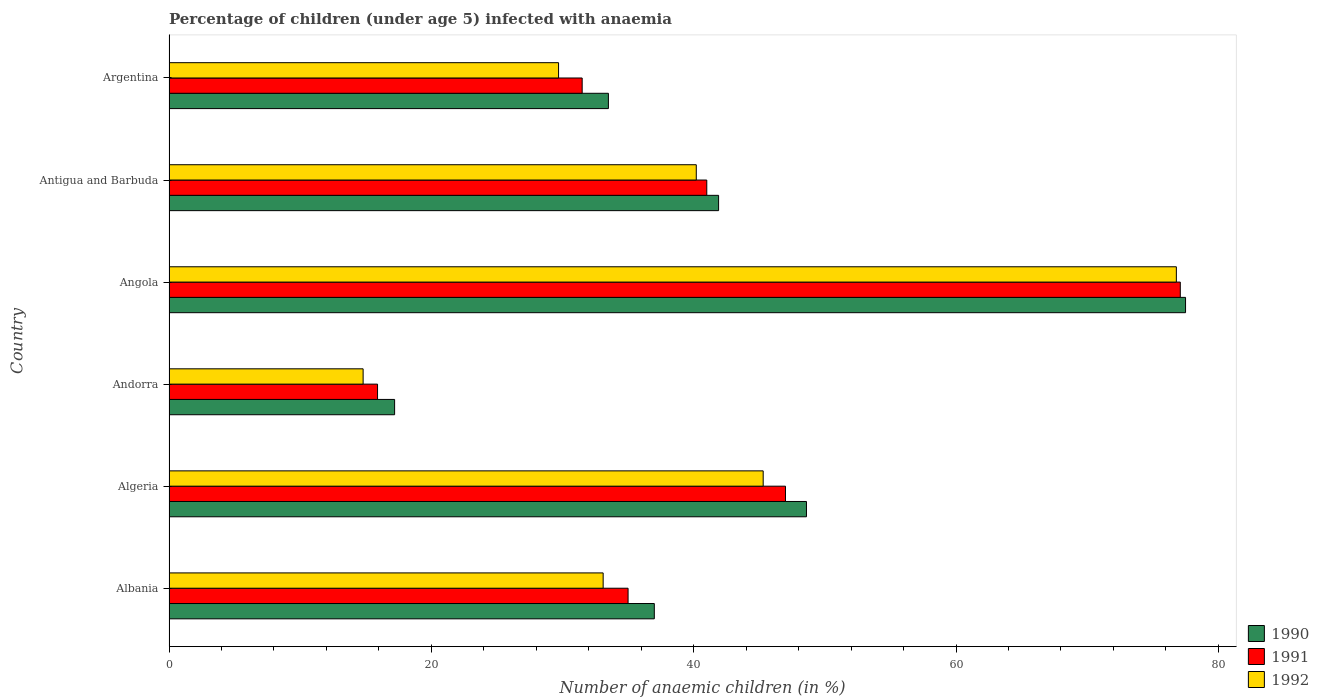How many different coloured bars are there?
Offer a very short reply. 3. Are the number of bars per tick equal to the number of legend labels?
Your response must be concise. Yes. Are the number of bars on each tick of the Y-axis equal?
Ensure brevity in your answer.  Yes. How many bars are there on the 5th tick from the bottom?
Your answer should be compact. 3. What is the label of the 6th group of bars from the top?
Offer a very short reply. Albania. Across all countries, what is the maximum percentage of children infected with anaemia in in 1991?
Your response must be concise. 77.1. Across all countries, what is the minimum percentage of children infected with anaemia in in 1991?
Keep it short and to the point. 15.9. In which country was the percentage of children infected with anaemia in in 1992 maximum?
Offer a terse response. Angola. In which country was the percentage of children infected with anaemia in in 1992 minimum?
Provide a succinct answer. Andorra. What is the total percentage of children infected with anaemia in in 1992 in the graph?
Keep it short and to the point. 239.9. What is the difference between the percentage of children infected with anaemia in in 1991 in Albania and that in Algeria?
Offer a very short reply. -12. What is the difference between the percentage of children infected with anaemia in in 1991 in Argentina and the percentage of children infected with anaemia in in 1990 in Antigua and Barbuda?
Offer a very short reply. -10.4. What is the average percentage of children infected with anaemia in in 1991 per country?
Your answer should be compact. 41.25. What is the difference between the percentage of children infected with anaemia in in 1992 and percentage of children infected with anaemia in in 1990 in Angola?
Provide a succinct answer. -0.7. In how many countries, is the percentage of children infected with anaemia in in 1991 greater than 56 %?
Your answer should be very brief. 1. What is the ratio of the percentage of children infected with anaemia in in 1990 in Andorra to that in Argentina?
Offer a very short reply. 0.51. Is the difference between the percentage of children infected with anaemia in in 1992 in Angola and Antigua and Barbuda greater than the difference between the percentage of children infected with anaemia in in 1990 in Angola and Antigua and Barbuda?
Ensure brevity in your answer.  Yes. What is the difference between the highest and the second highest percentage of children infected with anaemia in in 1992?
Make the answer very short. 31.5. What is the difference between the highest and the lowest percentage of children infected with anaemia in in 1990?
Your answer should be compact. 60.3. How many bars are there?
Your answer should be very brief. 18. Are all the bars in the graph horizontal?
Provide a short and direct response. Yes. How many countries are there in the graph?
Your response must be concise. 6. Are the values on the major ticks of X-axis written in scientific E-notation?
Offer a terse response. No. Does the graph contain any zero values?
Provide a short and direct response. No. How are the legend labels stacked?
Provide a short and direct response. Vertical. What is the title of the graph?
Keep it short and to the point. Percentage of children (under age 5) infected with anaemia. What is the label or title of the X-axis?
Your response must be concise. Number of anaemic children (in %). What is the Number of anaemic children (in %) in 1990 in Albania?
Give a very brief answer. 37. What is the Number of anaemic children (in %) in 1992 in Albania?
Keep it short and to the point. 33.1. What is the Number of anaemic children (in %) in 1990 in Algeria?
Your response must be concise. 48.6. What is the Number of anaemic children (in %) in 1992 in Algeria?
Give a very brief answer. 45.3. What is the Number of anaemic children (in %) in 1990 in Andorra?
Your answer should be very brief. 17.2. What is the Number of anaemic children (in %) in 1992 in Andorra?
Make the answer very short. 14.8. What is the Number of anaemic children (in %) in 1990 in Angola?
Make the answer very short. 77.5. What is the Number of anaemic children (in %) of 1991 in Angola?
Offer a very short reply. 77.1. What is the Number of anaemic children (in %) in 1992 in Angola?
Offer a terse response. 76.8. What is the Number of anaemic children (in %) in 1990 in Antigua and Barbuda?
Provide a short and direct response. 41.9. What is the Number of anaemic children (in %) in 1991 in Antigua and Barbuda?
Your answer should be very brief. 41. What is the Number of anaemic children (in %) in 1992 in Antigua and Barbuda?
Make the answer very short. 40.2. What is the Number of anaemic children (in %) of 1990 in Argentina?
Keep it short and to the point. 33.5. What is the Number of anaemic children (in %) of 1991 in Argentina?
Offer a terse response. 31.5. What is the Number of anaemic children (in %) in 1992 in Argentina?
Offer a terse response. 29.7. Across all countries, what is the maximum Number of anaemic children (in %) in 1990?
Offer a very short reply. 77.5. Across all countries, what is the maximum Number of anaemic children (in %) of 1991?
Give a very brief answer. 77.1. Across all countries, what is the maximum Number of anaemic children (in %) of 1992?
Keep it short and to the point. 76.8. Across all countries, what is the minimum Number of anaemic children (in %) of 1990?
Your response must be concise. 17.2. Across all countries, what is the minimum Number of anaemic children (in %) in 1992?
Ensure brevity in your answer.  14.8. What is the total Number of anaemic children (in %) of 1990 in the graph?
Ensure brevity in your answer.  255.7. What is the total Number of anaemic children (in %) in 1991 in the graph?
Your response must be concise. 247.5. What is the total Number of anaemic children (in %) of 1992 in the graph?
Make the answer very short. 239.9. What is the difference between the Number of anaemic children (in %) in 1990 in Albania and that in Algeria?
Give a very brief answer. -11.6. What is the difference between the Number of anaemic children (in %) in 1991 in Albania and that in Algeria?
Your answer should be compact. -12. What is the difference between the Number of anaemic children (in %) of 1992 in Albania and that in Algeria?
Provide a short and direct response. -12.2. What is the difference between the Number of anaemic children (in %) of 1990 in Albania and that in Andorra?
Your response must be concise. 19.8. What is the difference between the Number of anaemic children (in %) of 1992 in Albania and that in Andorra?
Make the answer very short. 18.3. What is the difference between the Number of anaemic children (in %) in 1990 in Albania and that in Angola?
Make the answer very short. -40.5. What is the difference between the Number of anaemic children (in %) in 1991 in Albania and that in Angola?
Give a very brief answer. -42.1. What is the difference between the Number of anaemic children (in %) in 1992 in Albania and that in Angola?
Your answer should be very brief. -43.7. What is the difference between the Number of anaemic children (in %) of 1992 in Albania and that in Antigua and Barbuda?
Offer a terse response. -7.1. What is the difference between the Number of anaemic children (in %) in 1991 in Albania and that in Argentina?
Keep it short and to the point. 3.5. What is the difference between the Number of anaemic children (in %) in 1990 in Algeria and that in Andorra?
Your answer should be compact. 31.4. What is the difference between the Number of anaemic children (in %) of 1991 in Algeria and that in Andorra?
Your response must be concise. 31.1. What is the difference between the Number of anaemic children (in %) of 1992 in Algeria and that in Andorra?
Your answer should be very brief. 30.5. What is the difference between the Number of anaemic children (in %) of 1990 in Algeria and that in Angola?
Your answer should be compact. -28.9. What is the difference between the Number of anaemic children (in %) in 1991 in Algeria and that in Angola?
Keep it short and to the point. -30.1. What is the difference between the Number of anaemic children (in %) of 1992 in Algeria and that in Angola?
Your response must be concise. -31.5. What is the difference between the Number of anaemic children (in %) in 1990 in Algeria and that in Antigua and Barbuda?
Offer a terse response. 6.7. What is the difference between the Number of anaemic children (in %) of 1991 in Algeria and that in Antigua and Barbuda?
Make the answer very short. 6. What is the difference between the Number of anaemic children (in %) in 1991 in Algeria and that in Argentina?
Ensure brevity in your answer.  15.5. What is the difference between the Number of anaemic children (in %) in 1990 in Andorra and that in Angola?
Your answer should be compact. -60.3. What is the difference between the Number of anaemic children (in %) in 1991 in Andorra and that in Angola?
Keep it short and to the point. -61.2. What is the difference between the Number of anaemic children (in %) of 1992 in Andorra and that in Angola?
Give a very brief answer. -62. What is the difference between the Number of anaemic children (in %) of 1990 in Andorra and that in Antigua and Barbuda?
Keep it short and to the point. -24.7. What is the difference between the Number of anaemic children (in %) of 1991 in Andorra and that in Antigua and Barbuda?
Your answer should be very brief. -25.1. What is the difference between the Number of anaemic children (in %) of 1992 in Andorra and that in Antigua and Barbuda?
Offer a very short reply. -25.4. What is the difference between the Number of anaemic children (in %) of 1990 in Andorra and that in Argentina?
Offer a very short reply. -16.3. What is the difference between the Number of anaemic children (in %) in 1991 in Andorra and that in Argentina?
Keep it short and to the point. -15.6. What is the difference between the Number of anaemic children (in %) of 1992 in Andorra and that in Argentina?
Keep it short and to the point. -14.9. What is the difference between the Number of anaemic children (in %) of 1990 in Angola and that in Antigua and Barbuda?
Ensure brevity in your answer.  35.6. What is the difference between the Number of anaemic children (in %) of 1991 in Angola and that in Antigua and Barbuda?
Make the answer very short. 36.1. What is the difference between the Number of anaemic children (in %) in 1992 in Angola and that in Antigua and Barbuda?
Your answer should be very brief. 36.6. What is the difference between the Number of anaemic children (in %) in 1991 in Angola and that in Argentina?
Provide a succinct answer. 45.6. What is the difference between the Number of anaemic children (in %) of 1992 in Angola and that in Argentina?
Give a very brief answer. 47.1. What is the difference between the Number of anaemic children (in %) in 1990 in Albania and the Number of anaemic children (in %) in 1991 in Algeria?
Make the answer very short. -10. What is the difference between the Number of anaemic children (in %) in 1991 in Albania and the Number of anaemic children (in %) in 1992 in Algeria?
Make the answer very short. -10.3. What is the difference between the Number of anaemic children (in %) in 1990 in Albania and the Number of anaemic children (in %) in 1991 in Andorra?
Provide a short and direct response. 21.1. What is the difference between the Number of anaemic children (in %) of 1990 in Albania and the Number of anaemic children (in %) of 1992 in Andorra?
Your answer should be very brief. 22.2. What is the difference between the Number of anaemic children (in %) of 1991 in Albania and the Number of anaemic children (in %) of 1992 in Andorra?
Provide a short and direct response. 20.2. What is the difference between the Number of anaemic children (in %) in 1990 in Albania and the Number of anaemic children (in %) in 1991 in Angola?
Your response must be concise. -40.1. What is the difference between the Number of anaemic children (in %) in 1990 in Albania and the Number of anaemic children (in %) in 1992 in Angola?
Ensure brevity in your answer.  -39.8. What is the difference between the Number of anaemic children (in %) of 1991 in Albania and the Number of anaemic children (in %) of 1992 in Angola?
Make the answer very short. -41.8. What is the difference between the Number of anaemic children (in %) in 1990 in Albania and the Number of anaemic children (in %) in 1991 in Antigua and Barbuda?
Ensure brevity in your answer.  -4. What is the difference between the Number of anaemic children (in %) of 1990 in Albania and the Number of anaemic children (in %) of 1991 in Argentina?
Provide a succinct answer. 5.5. What is the difference between the Number of anaemic children (in %) of 1990 in Algeria and the Number of anaemic children (in %) of 1991 in Andorra?
Keep it short and to the point. 32.7. What is the difference between the Number of anaemic children (in %) in 1990 in Algeria and the Number of anaemic children (in %) in 1992 in Andorra?
Ensure brevity in your answer.  33.8. What is the difference between the Number of anaemic children (in %) in 1991 in Algeria and the Number of anaemic children (in %) in 1992 in Andorra?
Give a very brief answer. 32.2. What is the difference between the Number of anaemic children (in %) of 1990 in Algeria and the Number of anaemic children (in %) of 1991 in Angola?
Offer a terse response. -28.5. What is the difference between the Number of anaemic children (in %) in 1990 in Algeria and the Number of anaemic children (in %) in 1992 in Angola?
Ensure brevity in your answer.  -28.2. What is the difference between the Number of anaemic children (in %) in 1991 in Algeria and the Number of anaemic children (in %) in 1992 in Angola?
Keep it short and to the point. -29.8. What is the difference between the Number of anaemic children (in %) in 1991 in Algeria and the Number of anaemic children (in %) in 1992 in Antigua and Barbuda?
Keep it short and to the point. 6.8. What is the difference between the Number of anaemic children (in %) of 1990 in Algeria and the Number of anaemic children (in %) of 1992 in Argentina?
Keep it short and to the point. 18.9. What is the difference between the Number of anaemic children (in %) of 1990 in Andorra and the Number of anaemic children (in %) of 1991 in Angola?
Ensure brevity in your answer.  -59.9. What is the difference between the Number of anaemic children (in %) in 1990 in Andorra and the Number of anaemic children (in %) in 1992 in Angola?
Your answer should be very brief. -59.6. What is the difference between the Number of anaemic children (in %) in 1991 in Andorra and the Number of anaemic children (in %) in 1992 in Angola?
Offer a terse response. -60.9. What is the difference between the Number of anaemic children (in %) in 1990 in Andorra and the Number of anaemic children (in %) in 1991 in Antigua and Barbuda?
Offer a terse response. -23.8. What is the difference between the Number of anaemic children (in %) in 1990 in Andorra and the Number of anaemic children (in %) in 1992 in Antigua and Barbuda?
Provide a short and direct response. -23. What is the difference between the Number of anaemic children (in %) of 1991 in Andorra and the Number of anaemic children (in %) of 1992 in Antigua and Barbuda?
Your answer should be very brief. -24.3. What is the difference between the Number of anaemic children (in %) of 1990 in Andorra and the Number of anaemic children (in %) of 1991 in Argentina?
Give a very brief answer. -14.3. What is the difference between the Number of anaemic children (in %) in 1990 in Andorra and the Number of anaemic children (in %) in 1992 in Argentina?
Your answer should be very brief. -12.5. What is the difference between the Number of anaemic children (in %) in 1991 in Andorra and the Number of anaemic children (in %) in 1992 in Argentina?
Make the answer very short. -13.8. What is the difference between the Number of anaemic children (in %) in 1990 in Angola and the Number of anaemic children (in %) in 1991 in Antigua and Barbuda?
Provide a short and direct response. 36.5. What is the difference between the Number of anaemic children (in %) of 1990 in Angola and the Number of anaemic children (in %) of 1992 in Antigua and Barbuda?
Give a very brief answer. 37.3. What is the difference between the Number of anaemic children (in %) in 1991 in Angola and the Number of anaemic children (in %) in 1992 in Antigua and Barbuda?
Ensure brevity in your answer.  36.9. What is the difference between the Number of anaemic children (in %) in 1990 in Angola and the Number of anaemic children (in %) in 1992 in Argentina?
Offer a very short reply. 47.8. What is the difference between the Number of anaemic children (in %) in 1991 in Angola and the Number of anaemic children (in %) in 1992 in Argentina?
Your response must be concise. 47.4. What is the average Number of anaemic children (in %) of 1990 per country?
Offer a very short reply. 42.62. What is the average Number of anaemic children (in %) of 1991 per country?
Your answer should be very brief. 41.25. What is the average Number of anaemic children (in %) in 1992 per country?
Offer a very short reply. 39.98. What is the difference between the Number of anaemic children (in %) in 1990 and Number of anaemic children (in %) in 1991 in Albania?
Make the answer very short. 2. What is the difference between the Number of anaemic children (in %) in 1990 and Number of anaemic children (in %) in 1991 in Algeria?
Your response must be concise. 1.6. What is the difference between the Number of anaemic children (in %) in 1990 and Number of anaemic children (in %) in 1992 in Algeria?
Ensure brevity in your answer.  3.3. What is the difference between the Number of anaemic children (in %) in 1991 and Number of anaemic children (in %) in 1992 in Algeria?
Your answer should be compact. 1.7. What is the difference between the Number of anaemic children (in %) in 1990 and Number of anaemic children (in %) in 1991 in Andorra?
Make the answer very short. 1.3. What is the difference between the Number of anaemic children (in %) in 1990 and Number of anaemic children (in %) in 1992 in Andorra?
Offer a terse response. 2.4. What is the difference between the Number of anaemic children (in %) of 1990 and Number of anaemic children (in %) of 1992 in Angola?
Provide a short and direct response. 0.7. What is the difference between the Number of anaemic children (in %) of 1991 and Number of anaemic children (in %) of 1992 in Angola?
Give a very brief answer. 0.3. What is the difference between the Number of anaemic children (in %) in 1990 and Number of anaemic children (in %) in 1991 in Antigua and Barbuda?
Ensure brevity in your answer.  0.9. What is the difference between the Number of anaemic children (in %) of 1990 and Number of anaemic children (in %) of 1992 in Antigua and Barbuda?
Your answer should be very brief. 1.7. What is the difference between the Number of anaemic children (in %) in 1990 and Number of anaemic children (in %) in 1991 in Argentina?
Make the answer very short. 2. What is the ratio of the Number of anaemic children (in %) in 1990 in Albania to that in Algeria?
Give a very brief answer. 0.76. What is the ratio of the Number of anaemic children (in %) in 1991 in Albania to that in Algeria?
Provide a short and direct response. 0.74. What is the ratio of the Number of anaemic children (in %) in 1992 in Albania to that in Algeria?
Provide a short and direct response. 0.73. What is the ratio of the Number of anaemic children (in %) of 1990 in Albania to that in Andorra?
Your answer should be very brief. 2.15. What is the ratio of the Number of anaemic children (in %) in 1991 in Albania to that in Andorra?
Provide a short and direct response. 2.2. What is the ratio of the Number of anaemic children (in %) of 1992 in Albania to that in Andorra?
Offer a terse response. 2.24. What is the ratio of the Number of anaemic children (in %) in 1990 in Albania to that in Angola?
Make the answer very short. 0.48. What is the ratio of the Number of anaemic children (in %) in 1991 in Albania to that in Angola?
Give a very brief answer. 0.45. What is the ratio of the Number of anaemic children (in %) in 1992 in Albania to that in Angola?
Offer a very short reply. 0.43. What is the ratio of the Number of anaemic children (in %) in 1990 in Albania to that in Antigua and Barbuda?
Your answer should be very brief. 0.88. What is the ratio of the Number of anaemic children (in %) in 1991 in Albania to that in Antigua and Barbuda?
Ensure brevity in your answer.  0.85. What is the ratio of the Number of anaemic children (in %) in 1992 in Albania to that in Antigua and Barbuda?
Keep it short and to the point. 0.82. What is the ratio of the Number of anaemic children (in %) of 1990 in Albania to that in Argentina?
Your answer should be very brief. 1.1. What is the ratio of the Number of anaemic children (in %) in 1991 in Albania to that in Argentina?
Offer a terse response. 1.11. What is the ratio of the Number of anaemic children (in %) of 1992 in Albania to that in Argentina?
Your response must be concise. 1.11. What is the ratio of the Number of anaemic children (in %) in 1990 in Algeria to that in Andorra?
Give a very brief answer. 2.83. What is the ratio of the Number of anaemic children (in %) of 1991 in Algeria to that in Andorra?
Provide a succinct answer. 2.96. What is the ratio of the Number of anaemic children (in %) in 1992 in Algeria to that in Andorra?
Keep it short and to the point. 3.06. What is the ratio of the Number of anaemic children (in %) of 1990 in Algeria to that in Angola?
Your response must be concise. 0.63. What is the ratio of the Number of anaemic children (in %) of 1991 in Algeria to that in Angola?
Make the answer very short. 0.61. What is the ratio of the Number of anaemic children (in %) of 1992 in Algeria to that in Angola?
Offer a terse response. 0.59. What is the ratio of the Number of anaemic children (in %) in 1990 in Algeria to that in Antigua and Barbuda?
Your answer should be compact. 1.16. What is the ratio of the Number of anaemic children (in %) of 1991 in Algeria to that in Antigua and Barbuda?
Offer a terse response. 1.15. What is the ratio of the Number of anaemic children (in %) in 1992 in Algeria to that in Antigua and Barbuda?
Your answer should be very brief. 1.13. What is the ratio of the Number of anaemic children (in %) in 1990 in Algeria to that in Argentina?
Your answer should be very brief. 1.45. What is the ratio of the Number of anaemic children (in %) of 1991 in Algeria to that in Argentina?
Provide a succinct answer. 1.49. What is the ratio of the Number of anaemic children (in %) of 1992 in Algeria to that in Argentina?
Your answer should be very brief. 1.53. What is the ratio of the Number of anaemic children (in %) in 1990 in Andorra to that in Angola?
Provide a short and direct response. 0.22. What is the ratio of the Number of anaemic children (in %) in 1991 in Andorra to that in Angola?
Your answer should be very brief. 0.21. What is the ratio of the Number of anaemic children (in %) in 1992 in Andorra to that in Angola?
Your response must be concise. 0.19. What is the ratio of the Number of anaemic children (in %) in 1990 in Andorra to that in Antigua and Barbuda?
Your answer should be very brief. 0.41. What is the ratio of the Number of anaemic children (in %) of 1991 in Andorra to that in Antigua and Barbuda?
Make the answer very short. 0.39. What is the ratio of the Number of anaemic children (in %) in 1992 in Andorra to that in Antigua and Barbuda?
Provide a succinct answer. 0.37. What is the ratio of the Number of anaemic children (in %) of 1990 in Andorra to that in Argentina?
Offer a terse response. 0.51. What is the ratio of the Number of anaemic children (in %) in 1991 in Andorra to that in Argentina?
Your answer should be very brief. 0.5. What is the ratio of the Number of anaemic children (in %) of 1992 in Andorra to that in Argentina?
Provide a short and direct response. 0.5. What is the ratio of the Number of anaemic children (in %) in 1990 in Angola to that in Antigua and Barbuda?
Your answer should be very brief. 1.85. What is the ratio of the Number of anaemic children (in %) of 1991 in Angola to that in Antigua and Barbuda?
Provide a short and direct response. 1.88. What is the ratio of the Number of anaemic children (in %) in 1992 in Angola to that in Antigua and Barbuda?
Provide a succinct answer. 1.91. What is the ratio of the Number of anaemic children (in %) of 1990 in Angola to that in Argentina?
Offer a terse response. 2.31. What is the ratio of the Number of anaemic children (in %) in 1991 in Angola to that in Argentina?
Ensure brevity in your answer.  2.45. What is the ratio of the Number of anaemic children (in %) of 1992 in Angola to that in Argentina?
Keep it short and to the point. 2.59. What is the ratio of the Number of anaemic children (in %) of 1990 in Antigua and Barbuda to that in Argentina?
Keep it short and to the point. 1.25. What is the ratio of the Number of anaemic children (in %) in 1991 in Antigua and Barbuda to that in Argentina?
Your answer should be compact. 1.3. What is the ratio of the Number of anaemic children (in %) in 1992 in Antigua and Barbuda to that in Argentina?
Provide a succinct answer. 1.35. What is the difference between the highest and the second highest Number of anaemic children (in %) of 1990?
Offer a terse response. 28.9. What is the difference between the highest and the second highest Number of anaemic children (in %) of 1991?
Offer a very short reply. 30.1. What is the difference between the highest and the second highest Number of anaemic children (in %) in 1992?
Offer a very short reply. 31.5. What is the difference between the highest and the lowest Number of anaemic children (in %) in 1990?
Provide a succinct answer. 60.3. What is the difference between the highest and the lowest Number of anaemic children (in %) in 1991?
Make the answer very short. 61.2. 